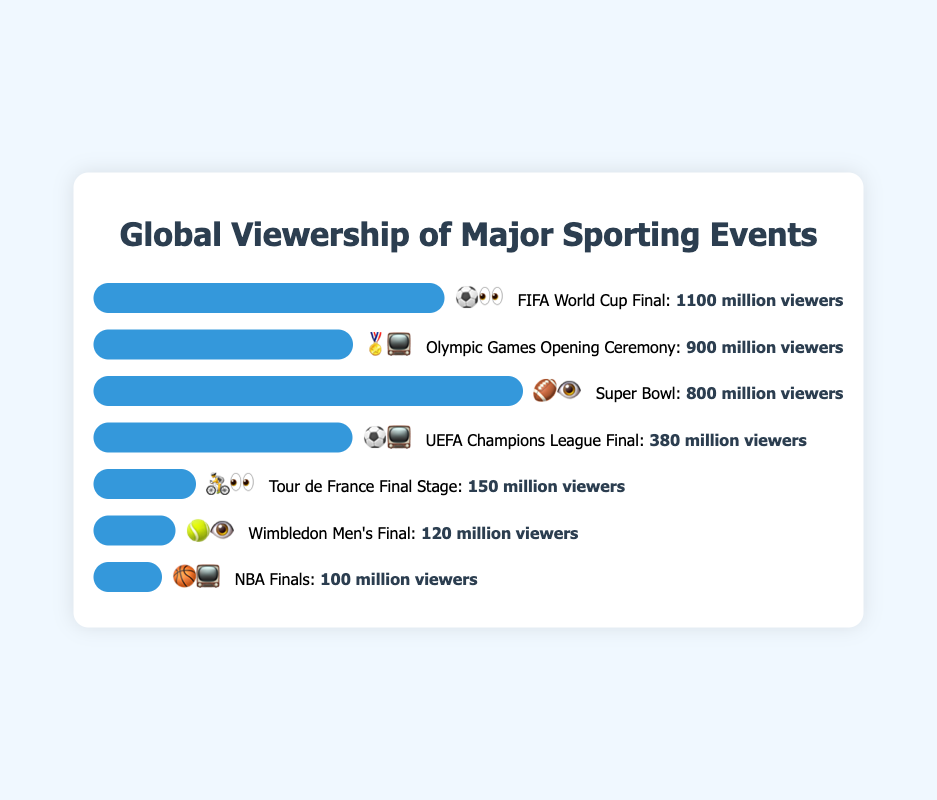Which event has the highest viewership? The event with the highest viewership is at the top of the chart and has the longest bar.
Answer: FIFA World Cup Final What is the total viewership of the top three events combined? Add the viewership of the FIFA World Cup Final (1100 million viewers), Olympic Games Opening Ceremony (900 million viewers), and Super Bowl (800 million viewers). 1100 + 900 + 800 = 2800
Answer: 2800 million viewers Which event has fewer viewers: Wimbledon Men's Final or NBA Finals? Compare the viewership numbers for Wimbledon Men's Final (120 million viewers) and NBA Finals (100 million viewers).
Answer: NBA Finals How many events have a viewership of less than 200 million viewers? Count the number of events where the viewership bar is less than 200 million viewers. This includes the Wimbledon Men's Final (120 million viewers) and the NBA Finals (100 million viewers).
Answer: 2 events What's the difference in viewership between the UEFA Champions League Final and the Tour de France Final Stage? Subtract the viewership of the Tour de France Final Stage (150 million viewers) from the UEFA Champions League Final (380 million viewers). 380 - 150 = 230
Answer: 230 million viewers Which event is represented by the emoji "🏅📺"? Identify the event associated with the "🏅📺" emoji from the chart.
Answer: Olympic Games Opening Ceremony By how much does the Super Bowl viewership exceed the UEFA Champions League Final? Subtract the viewership of the UEFA Champions League Final (380 million viewers) from the Super Bowl (800 million viewers). 800 - 380 = 420
Answer: 420 million viewers What is the viewership unit mentioned in the chart? Refer to the description of the viewership unit next to the bars in the chart.
Answer: million viewers 